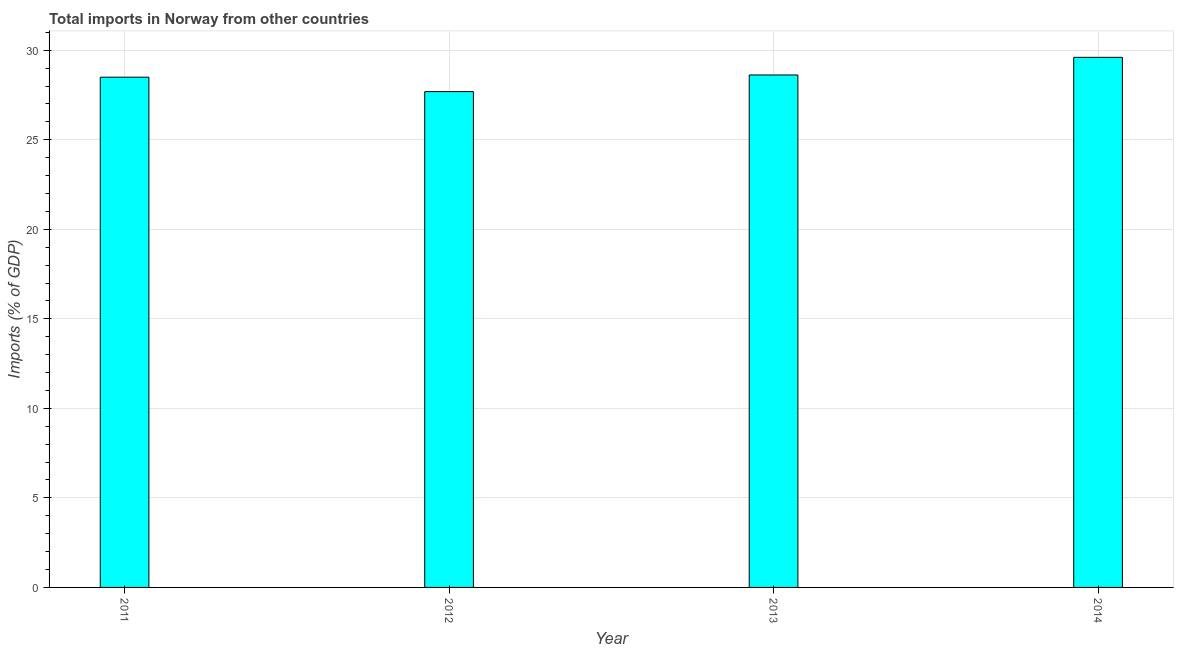Does the graph contain any zero values?
Your response must be concise. No. Does the graph contain grids?
Your answer should be very brief. Yes. What is the title of the graph?
Provide a short and direct response. Total imports in Norway from other countries. What is the label or title of the X-axis?
Offer a very short reply. Year. What is the label or title of the Y-axis?
Offer a terse response. Imports (% of GDP). What is the total imports in 2014?
Give a very brief answer. 29.6. Across all years, what is the maximum total imports?
Offer a terse response. 29.6. Across all years, what is the minimum total imports?
Give a very brief answer. 27.69. In which year was the total imports minimum?
Your answer should be very brief. 2012. What is the sum of the total imports?
Give a very brief answer. 114.41. What is the difference between the total imports in 2011 and 2013?
Offer a terse response. -0.12. What is the average total imports per year?
Offer a terse response. 28.6. What is the median total imports?
Keep it short and to the point. 28.56. Do a majority of the years between 2014 and 2011 (inclusive) have total imports greater than 18 %?
Give a very brief answer. Yes. Is the sum of the total imports in 2011 and 2014 greater than the maximum total imports across all years?
Your answer should be compact. Yes. What is the difference between the highest and the lowest total imports?
Your answer should be very brief. 1.91. How many bars are there?
Provide a short and direct response. 4. Are the values on the major ticks of Y-axis written in scientific E-notation?
Offer a very short reply. No. What is the Imports (% of GDP) in 2011?
Provide a succinct answer. 28.5. What is the Imports (% of GDP) of 2012?
Ensure brevity in your answer.  27.69. What is the Imports (% of GDP) of 2013?
Your response must be concise. 28.62. What is the Imports (% of GDP) of 2014?
Your answer should be compact. 29.6. What is the difference between the Imports (% of GDP) in 2011 and 2012?
Make the answer very short. 0.81. What is the difference between the Imports (% of GDP) in 2011 and 2013?
Ensure brevity in your answer.  -0.12. What is the difference between the Imports (% of GDP) in 2011 and 2014?
Offer a very short reply. -1.11. What is the difference between the Imports (% of GDP) in 2012 and 2013?
Your answer should be very brief. -0.93. What is the difference between the Imports (% of GDP) in 2012 and 2014?
Offer a terse response. -1.91. What is the difference between the Imports (% of GDP) in 2013 and 2014?
Offer a very short reply. -0.99. What is the ratio of the Imports (% of GDP) in 2011 to that in 2013?
Provide a succinct answer. 1. What is the ratio of the Imports (% of GDP) in 2012 to that in 2013?
Ensure brevity in your answer.  0.97. What is the ratio of the Imports (% of GDP) in 2012 to that in 2014?
Keep it short and to the point. 0.94. 